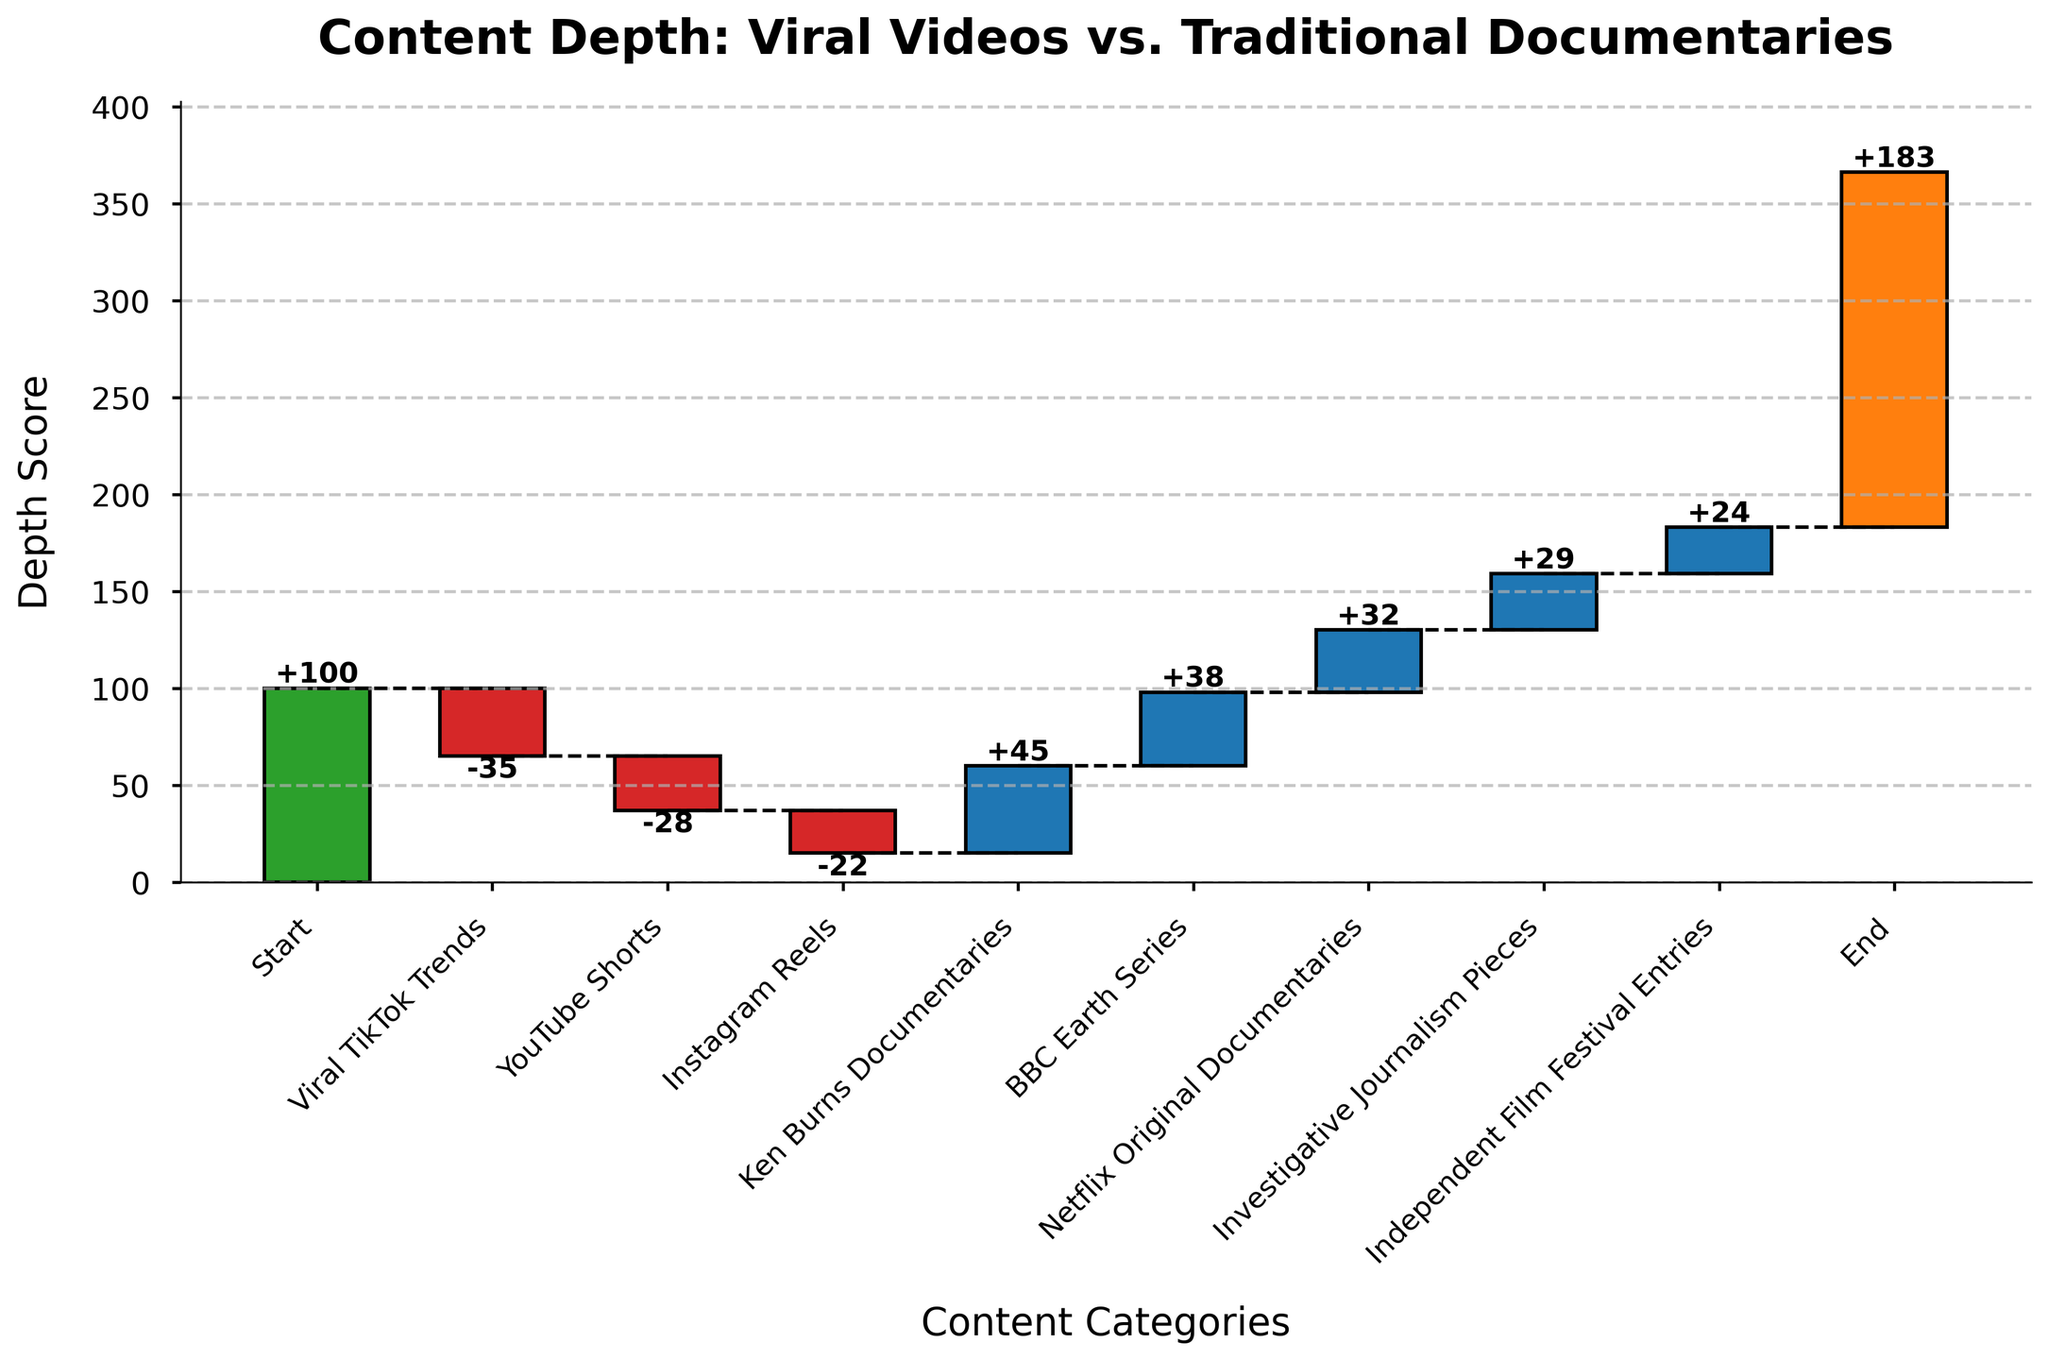What's the title of the chart? The title is usually located at the top of the chart and it summarizes the overall theme or focus. In this case, the title is clearly at the top.
Answer: Content Depth: Viral Videos vs. Traditional Documentaries How many content categories are represented in the chart? The x-axis of the chart displays the content categories, each labeled with a different type. By counting the labels from 'Start' to 'End', we can determine the total number.
Answer: 9 Which content category shows the largest positive value? Looking at the height of the bars for the positive values, we can identify the one with the highest positive contribution.
Answer: Ken Burns Documentaries What is the cumulative depth score at the 'End' category? The cumulative score is indicated by the endpoint of the final bar in the waterfall chart. This score includes the net effect of all preceding values.
Answer: 183 How much does BBC Earth Series contribute to the depth score? To find the contribution of BBC Earth Series, check the height of its corresponding bar, which is marked with '+38'.
Answer: +38 Which viral video platform has the least negative impact on content depth? Compare the negative values for TikTok, YouTube Shorts, and Instagram Reels, and identify the smallest (least negative) one.
Answer: Instagram Reels What's the cumulative depth score after accounting for YouTube Shorts? Add the starting point (100) with the impact from TikTok (-35) and then the impact from YouTube Shorts (-28).
Answer: 37 What is the combined impact of all traditional documentaries? Sum the individual positive values of Ken Burns Documentaries (+45), BBC Earth Series (+38), Netflix Original Documentaries (+32), Investigative Journalism Pieces (+29), and Independent Film Festival Entries (+24). Total these numbers for the cumulative impact.
Answer: 168 How does the depth score change from the 'Start' to 'Viral TikTok Trends'? The change in depth score from 'Start' to 'Viral TikTok Trends' is calculated by subtracting the negative impact of TikTok (-35) from the starting value (100).
Answer: -35 points What category has the smallest contribution to the depth score in traditional documentaries? Compare the positive values of the categories under traditional documentaries and identify the smallest impact.
Answer: Independent Film Festival Entries 